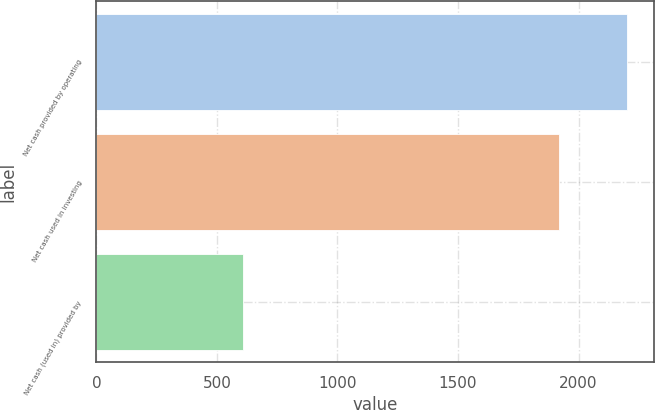<chart> <loc_0><loc_0><loc_500><loc_500><bar_chart><fcel>Net cash provided by operating<fcel>Net cash used in investing<fcel>Net cash (used in) provided by<nl><fcel>2202<fcel>1917<fcel>610<nl></chart> 